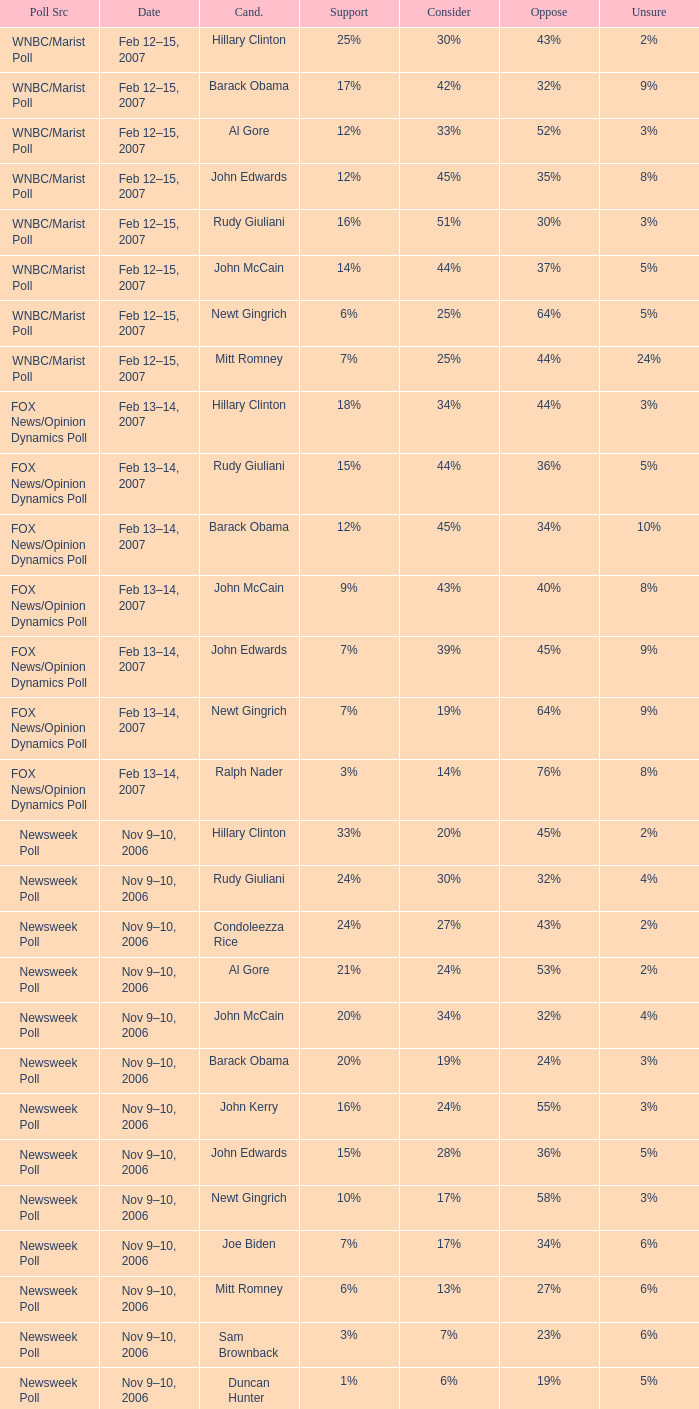What percentage of people said they would consider Rudy Giuliani as a candidate according to the Newsweek poll that showed 32% opposed him? 30%. 